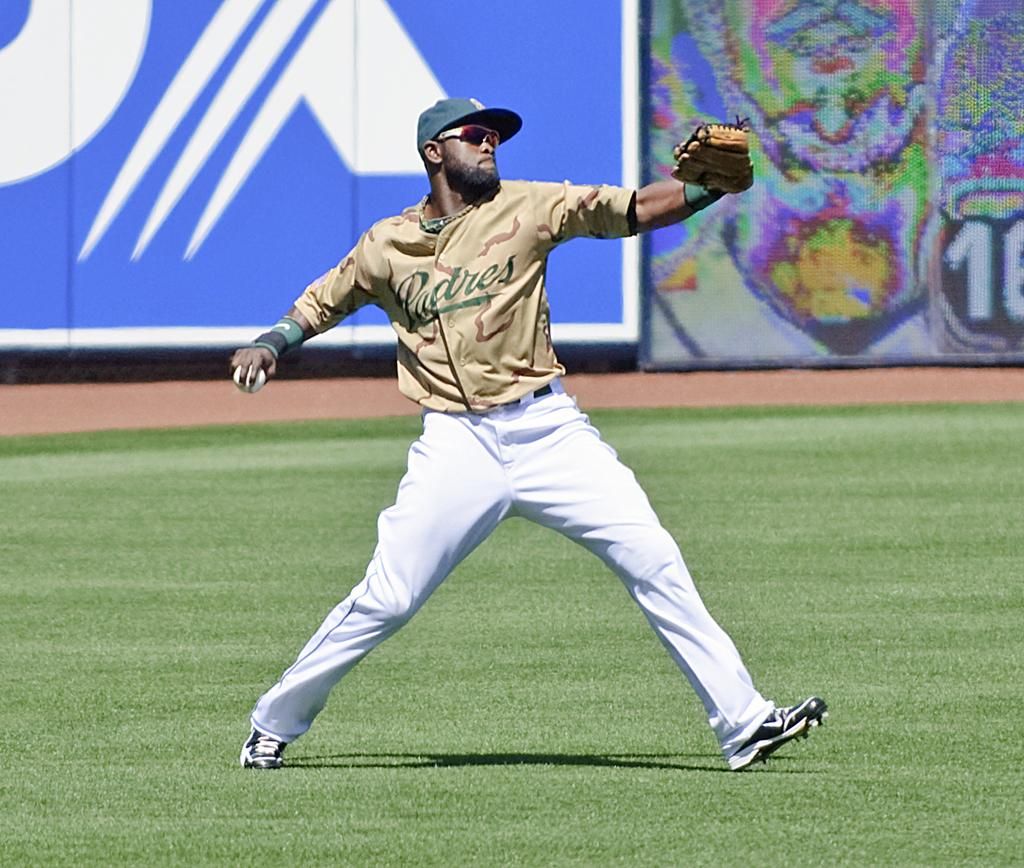<image>
Create a compact narrative representing the image presented. A baseball player wearing a jersey that says Padres gets ready to throw the ball. 